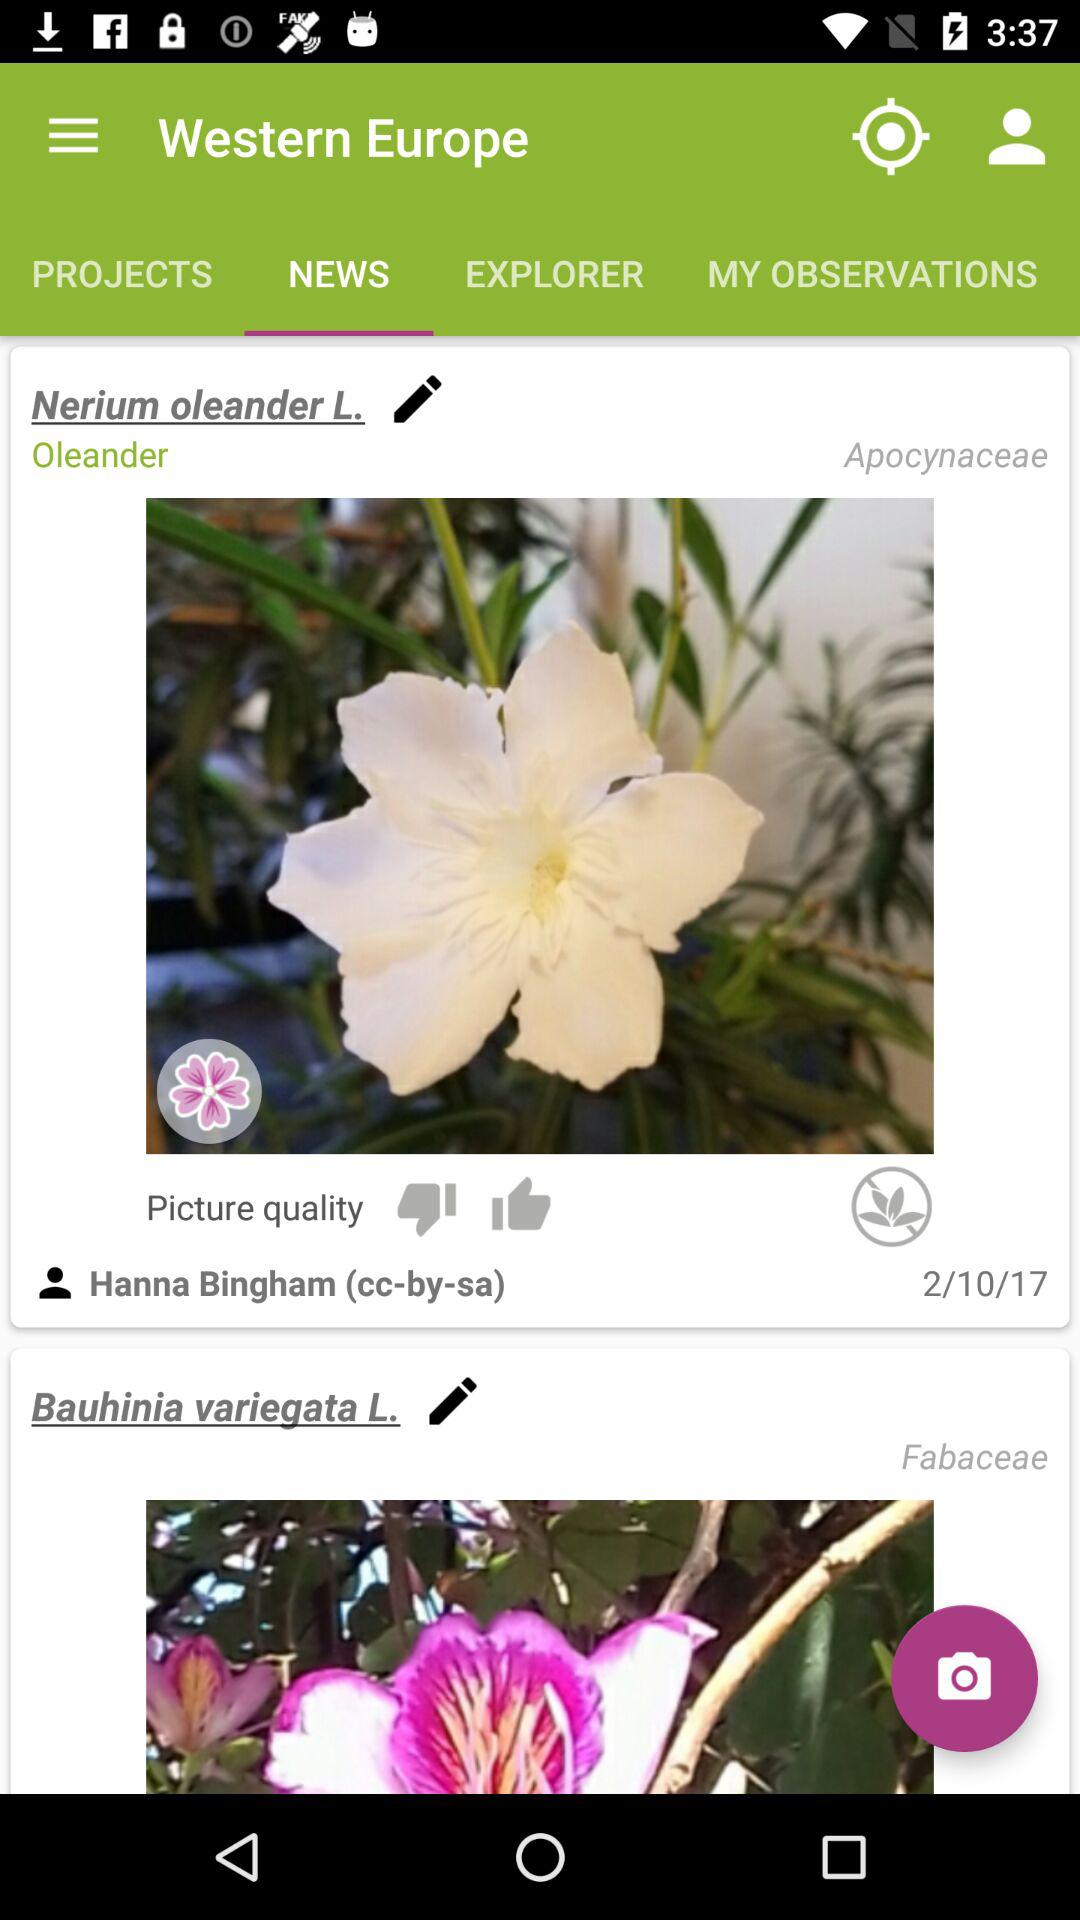When was the article published? The article was published on February 10, 2017. 